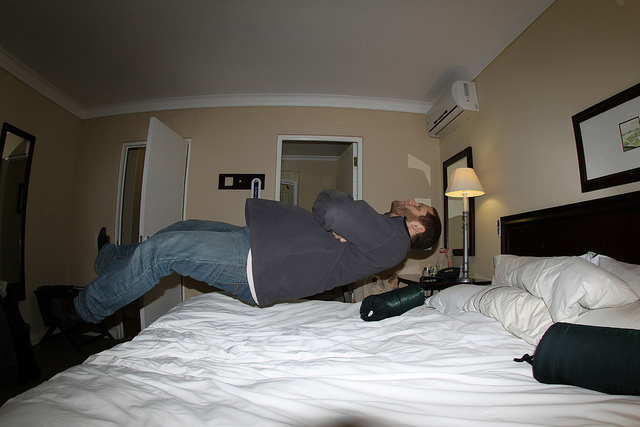How might this floating effect have been achieved in the photo? The floating effect in the photo appears to have been achieved through a clever combination of timing and camera angle. The man has likely jumped and assumed a relaxed, reclined position at the peak of his jump, while the photo was taken at an angle where the bed obscures his lower half, enhancing the illusion that he is levitating. 